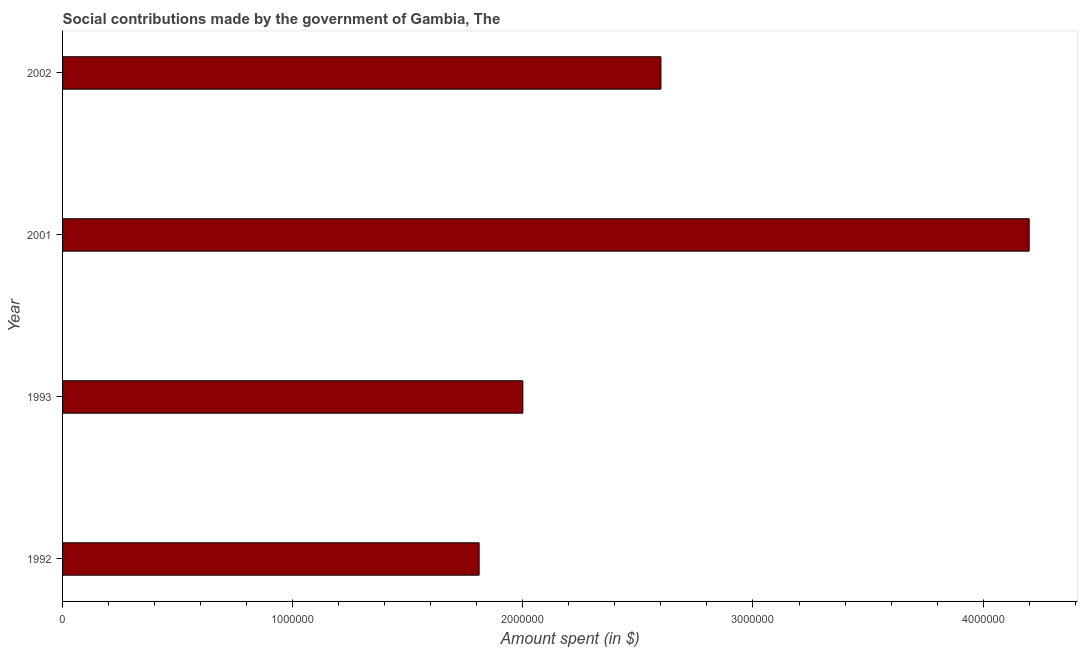Does the graph contain any zero values?
Your answer should be compact. No. What is the title of the graph?
Offer a very short reply. Social contributions made by the government of Gambia, The. What is the label or title of the X-axis?
Make the answer very short. Amount spent (in $). What is the label or title of the Y-axis?
Make the answer very short. Year. What is the amount spent in making social contributions in 2002?
Your answer should be compact. 2.60e+06. Across all years, what is the maximum amount spent in making social contributions?
Provide a succinct answer. 4.20e+06. Across all years, what is the minimum amount spent in making social contributions?
Offer a terse response. 1.81e+06. In which year was the amount spent in making social contributions maximum?
Your response must be concise. 2001. What is the sum of the amount spent in making social contributions?
Give a very brief answer. 1.06e+07. What is the difference between the amount spent in making social contributions in 1992 and 2002?
Your answer should be very brief. -7.90e+05. What is the average amount spent in making social contributions per year?
Give a very brief answer. 2.65e+06. What is the median amount spent in making social contributions?
Ensure brevity in your answer.  2.30e+06. What is the ratio of the amount spent in making social contributions in 2001 to that in 2002?
Keep it short and to the point. 1.61. Is the amount spent in making social contributions in 1993 less than that in 2002?
Your answer should be very brief. Yes. Is the difference between the amount spent in making social contributions in 1992 and 1993 greater than the difference between any two years?
Keep it short and to the point. No. What is the difference between the highest and the second highest amount spent in making social contributions?
Give a very brief answer. 1.60e+06. Is the sum of the amount spent in making social contributions in 1992 and 1993 greater than the maximum amount spent in making social contributions across all years?
Your answer should be very brief. No. What is the difference between the highest and the lowest amount spent in making social contributions?
Provide a succinct answer. 2.39e+06. What is the difference between two consecutive major ticks on the X-axis?
Your response must be concise. 1.00e+06. Are the values on the major ticks of X-axis written in scientific E-notation?
Ensure brevity in your answer.  No. What is the Amount spent (in $) in 1992?
Offer a terse response. 1.81e+06. What is the Amount spent (in $) in 2001?
Offer a terse response. 4.20e+06. What is the Amount spent (in $) of 2002?
Provide a succinct answer. 2.60e+06. What is the difference between the Amount spent (in $) in 1992 and 2001?
Make the answer very short. -2.39e+06. What is the difference between the Amount spent (in $) in 1992 and 2002?
Keep it short and to the point. -7.90e+05. What is the difference between the Amount spent (in $) in 1993 and 2001?
Your response must be concise. -2.20e+06. What is the difference between the Amount spent (in $) in 1993 and 2002?
Offer a very short reply. -6.00e+05. What is the difference between the Amount spent (in $) in 2001 and 2002?
Provide a succinct answer. 1.60e+06. What is the ratio of the Amount spent (in $) in 1992 to that in 1993?
Your answer should be very brief. 0.91. What is the ratio of the Amount spent (in $) in 1992 to that in 2001?
Make the answer very short. 0.43. What is the ratio of the Amount spent (in $) in 1992 to that in 2002?
Your answer should be very brief. 0.7. What is the ratio of the Amount spent (in $) in 1993 to that in 2001?
Make the answer very short. 0.48. What is the ratio of the Amount spent (in $) in 1993 to that in 2002?
Keep it short and to the point. 0.77. What is the ratio of the Amount spent (in $) in 2001 to that in 2002?
Your response must be concise. 1.61. 